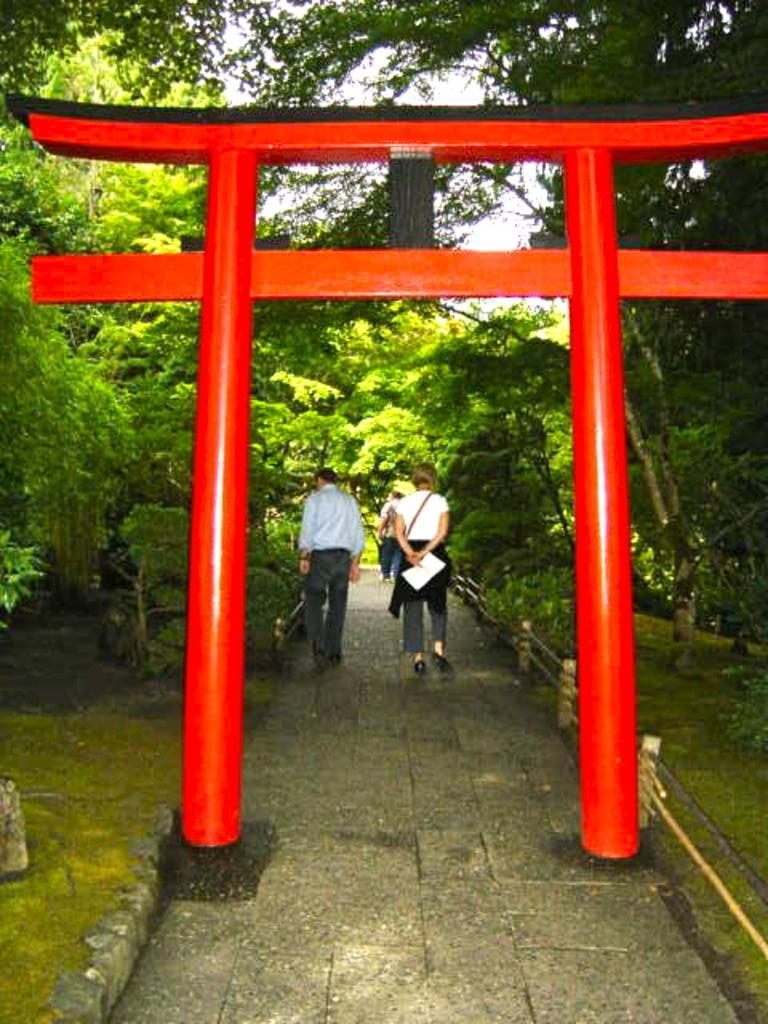Could you give a brief overview of what you see in this image? There is a red color arch on a road, on which there are persons. On both sides of this arch, there are trees and grass on the ground. In the background, there is the sky. 